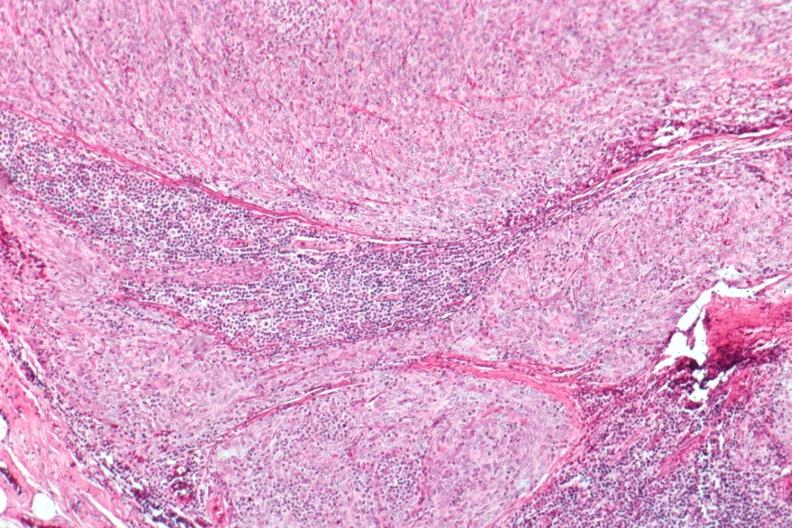s lymphangiomatosis generalized present?
Answer the question using a single word or phrase. No 